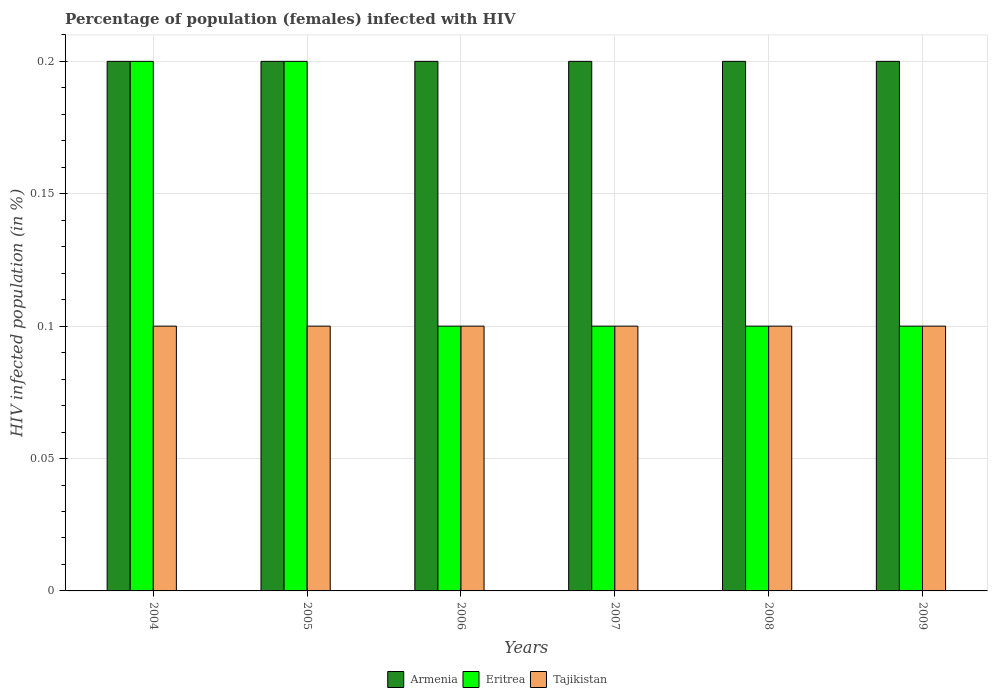Are the number of bars per tick equal to the number of legend labels?
Offer a very short reply. Yes. Are the number of bars on each tick of the X-axis equal?
Provide a short and direct response. Yes. How many bars are there on the 6th tick from the right?
Your response must be concise. 3. In how many cases, is the number of bars for a given year not equal to the number of legend labels?
Your answer should be very brief. 0. What is the percentage of HIV infected female population in Eritrea in 2009?
Make the answer very short. 0.1. Across all years, what is the minimum percentage of HIV infected female population in Tajikistan?
Ensure brevity in your answer.  0.1. In which year was the percentage of HIV infected female population in Armenia maximum?
Give a very brief answer. 2004. What is the total percentage of HIV infected female population in Tajikistan in the graph?
Offer a very short reply. 0.6. What is the difference between the percentage of HIV infected female population in Tajikistan in 2008 and that in 2009?
Make the answer very short. 0. What is the difference between the percentage of HIV infected female population in Tajikistan in 2009 and the percentage of HIV infected female population in Armenia in 2004?
Your answer should be very brief. -0.1. What is the average percentage of HIV infected female population in Eritrea per year?
Give a very brief answer. 0.13. In how many years, is the percentage of HIV infected female population in Eritrea greater than 0.17 %?
Your answer should be compact. 2. What is the ratio of the percentage of HIV infected female population in Armenia in 2004 to that in 2008?
Keep it short and to the point. 1. What is the difference between the highest and the second highest percentage of HIV infected female population in Tajikistan?
Give a very brief answer. 0. What does the 1st bar from the left in 2008 represents?
Your answer should be very brief. Armenia. What does the 1st bar from the right in 2008 represents?
Your response must be concise. Tajikistan. Is it the case that in every year, the sum of the percentage of HIV infected female population in Tajikistan and percentage of HIV infected female population in Eritrea is greater than the percentage of HIV infected female population in Armenia?
Give a very brief answer. No. How many years are there in the graph?
Your answer should be compact. 6. What is the difference between two consecutive major ticks on the Y-axis?
Provide a short and direct response. 0.05. Are the values on the major ticks of Y-axis written in scientific E-notation?
Ensure brevity in your answer.  No. Does the graph contain grids?
Ensure brevity in your answer.  Yes. What is the title of the graph?
Offer a terse response. Percentage of population (females) infected with HIV. What is the label or title of the X-axis?
Your answer should be very brief. Years. What is the label or title of the Y-axis?
Provide a short and direct response. HIV infected population (in %). What is the HIV infected population (in %) in Tajikistan in 2004?
Offer a very short reply. 0.1. What is the HIV infected population (in %) in Armenia in 2006?
Your response must be concise. 0.2. What is the HIV infected population (in %) in Eritrea in 2007?
Your response must be concise. 0.1. What is the HIV infected population (in %) in Armenia in 2008?
Give a very brief answer. 0.2. What is the HIV infected population (in %) of Eritrea in 2008?
Keep it short and to the point. 0.1. What is the HIV infected population (in %) in Tajikistan in 2008?
Provide a succinct answer. 0.1. What is the HIV infected population (in %) of Armenia in 2009?
Provide a short and direct response. 0.2. What is the HIV infected population (in %) in Eritrea in 2009?
Your answer should be compact. 0.1. What is the HIV infected population (in %) in Tajikistan in 2009?
Provide a short and direct response. 0.1. Across all years, what is the maximum HIV infected population (in %) in Eritrea?
Your response must be concise. 0.2. Across all years, what is the minimum HIV infected population (in %) in Tajikistan?
Offer a terse response. 0.1. What is the difference between the HIV infected population (in %) of Eritrea in 2004 and that in 2005?
Ensure brevity in your answer.  0. What is the difference between the HIV infected population (in %) of Tajikistan in 2004 and that in 2005?
Keep it short and to the point. 0. What is the difference between the HIV infected population (in %) of Armenia in 2004 and that in 2006?
Keep it short and to the point. 0. What is the difference between the HIV infected population (in %) of Eritrea in 2004 and that in 2006?
Offer a terse response. 0.1. What is the difference between the HIV infected population (in %) of Tajikistan in 2004 and that in 2006?
Your answer should be very brief. 0. What is the difference between the HIV infected population (in %) of Eritrea in 2004 and that in 2007?
Give a very brief answer. 0.1. What is the difference between the HIV infected population (in %) in Eritrea in 2004 and that in 2008?
Your answer should be very brief. 0.1. What is the difference between the HIV infected population (in %) of Eritrea in 2004 and that in 2009?
Give a very brief answer. 0.1. What is the difference between the HIV infected population (in %) of Tajikistan in 2004 and that in 2009?
Make the answer very short. 0. What is the difference between the HIV infected population (in %) in Armenia in 2005 and that in 2006?
Provide a short and direct response. 0. What is the difference between the HIV infected population (in %) in Tajikistan in 2005 and that in 2006?
Offer a terse response. 0. What is the difference between the HIV infected population (in %) in Tajikistan in 2005 and that in 2008?
Ensure brevity in your answer.  0. What is the difference between the HIV infected population (in %) of Armenia in 2005 and that in 2009?
Keep it short and to the point. 0. What is the difference between the HIV infected population (in %) of Eritrea in 2005 and that in 2009?
Ensure brevity in your answer.  0.1. What is the difference between the HIV infected population (in %) of Armenia in 2006 and that in 2007?
Ensure brevity in your answer.  0. What is the difference between the HIV infected population (in %) in Tajikistan in 2006 and that in 2007?
Provide a short and direct response. 0. What is the difference between the HIV infected population (in %) in Armenia in 2006 and that in 2008?
Provide a succinct answer. 0. What is the difference between the HIV infected population (in %) of Eritrea in 2006 and that in 2008?
Provide a short and direct response. 0. What is the difference between the HIV infected population (in %) in Armenia in 2006 and that in 2009?
Provide a short and direct response. 0. What is the difference between the HIV infected population (in %) in Tajikistan in 2007 and that in 2008?
Your answer should be very brief. 0. What is the difference between the HIV infected population (in %) in Tajikistan in 2007 and that in 2009?
Your answer should be very brief. 0. What is the difference between the HIV infected population (in %) of Tajikistan in 2008 and that in 2009?
Your response must be concise. 0. What is the difference between the HIV infected population (in %) of Armenia in 2004 and the HIV infected population (in %) of Eritrea in 2005?
Give a very brief answer. 0. What is the difference between the HIV infected population (in %) in Armenia in 2004 and the HIV infected population (in %) in Tajikistan in 2005?
Provide a short and direct response. 0.1. What is the difference between the HIV infected population (in %) of Armenia in 2004 and the HIV infected population (in %) of Eritrea in 2006?
Ensure brevity in your answer.  0.1. What is the difference between the HIV infected population (in %) of Eritrea in 2004 and the HIV infected population (in %) of Tajikistan in 2006?
Offer a terse response. 0.1. What is the difference between the HIV infected population (in %) of Armenia in 2004 and the HIV infected population (in %) of Eritrea in 2007?
Provide a succinct answer. 0.1. What is the difference between the HIV infected population (in %) in Armenia in 2004 and the HIV infected population (in %) in Eritrea in 2008?
Offer a terse response. 0.1. What is the difference between the HIV infected population (in %) in Armenia in 2005 and the HIV infected population (in %) in Tajikistan in 2006?
Your answer should be compact. 0.1. What is the difference between the HIV infected population (in %) of Eritrea in 2005 and the HIV infected population (in %) of Tajikistan in 2006?
Keep it short and to the point. 0.1. What is the difference between the HIV infected population (in %) of Armenia in 2005 and the HIV infected population (in %) of Tajikistan in 2007?
Offer a very short reply. 0.1. What is the difference between the HIV infected population (in %) of Eritrea in 2005 and the HIV infected population (in %) of Tajikistan in 2007?
Make the answer very short. 0.1. What is the difference between the HIV infected population (in %) of Armenia in 2005 and the HIV infected population (in %) of Tajikistan in 2008?
Offer a terse response. 0.1. What is the difference between the HIV infected population (in %) of Armenia in 2006 and the HIV infected population (in %) of Eritrea in 2007?
Provide a short and direct response. 0.1. What is the difference between the HIV infected population (in %) of Armenia in 2006 and the HIV infected population (in %) of Tajikistan in 2007?
Make the answer very short. 0.1. What is the difference between the HIV infected population (in %) in Eritrea in 2006 and the HIV infected population (in %) in Tajikistan in 2007?
Make the answer very short. 0. What is the difference between the HIV infected population (in %) in Armenia in 2006 and the HIV infected population (in %) in Eritrea in 2008?
Ensure brevity in your answer.  0.1. What is the difference between the HIV infected population (in %) in Eritrea in 2006 and the HIV infected population (in %) in Tajikistan in 2008?
Provide a short and direct response. 0. What is the difference between the HIV infected population (in %) in Armenia in 2006 and the HIV infected population (in %) in Eritrea in 2009?
Ensure brevity in your answer.  0.1. What is the difference between the HIV infected population (in %) in Armenia in 2006 and the HIV infected population (in %) in Tajikistan in 2009?
Your response must be concise. 0.1. What is the difference between the HIV infected population (in %) of Eritrea in 2006 and the HIV infected population (in %) of Tajikistan in 2009?
Your answer should be very brief. 0. What is the difference between the HIV infected population (in %) of Armenia in 2007 and the HIV infected population (in %) of Eritrea in 2008?
Offer a terse response. 0.1. What is the difference between the HIV infected population (in %) of Armenia in 2007 and the HIV infected population (in %) of Tajikistan in 2008?
Provide a succinct answer. 0.1. What is the difference between the HIV infected population (in %) of Armenia in 2007 and the HIV infected population (in %) of Eritrea in 2009?
Provide a short and direct response. 0.1. What is the difference between the HIV infected population (in %) in Armenia in 2007 and the HIV infected population (in %) in Tajikistan in 2009?
Make the answer very short. 0.1. What is the difference between the HIV infected population (in %) in Armenia in 2008 and the HIV infected population (in %) in Eritrea in 2009?
Your response must be concise. 0.1. What is the difference between the HIV infected population (in %) of Eritrea in 2008 and the HIV infected population (in %) of Tajikistan in 2009?
Your response must be concise. 0. What is the average HIV infected population (in %) of Armenia per year?
Keep it short and to the point. 0.2. What is the average HIV infected population (in %) in Eritrea per year?
Keep it short and to the point. 0.13. In the year 2004, what is the difference between the HIV infected population (in %) of Armenia and HIV infected population (in %) of Eritrea?
Ensure brevity in your answer.  0. In the year 2004, what is the difference between the HIV infected population (in %) in Armenia and HIV infected population (in %) in Tajikistan?
Provide a short and direct response. 0.1. In the year 2005, what is the difference between the HIV infected population (in %) in Armenia and HIV infected population (in %) in Tajikistan?
Provide a short and direct response. 0.1. In the year 2005, what is the difference between the HIV infected population (in %) of Eritrea and HIV infected population (in %) of Tajikistan?
Your answer should be very brief. 0.1. In the year 2006, what is the difference between the HIV infected population (in %) of Armenia and HIV infected population (in %) of Tajikistan?
Ensure brevity in your answer.  0.1. In the year 2007, what is the difference between the HIV infected population (in %) of Armenia and HIV infected population (in %) of Eritrea?
Make the answer very short. 0.1. In the year 2007, what is the difference between the HIV infected population (in %) of Armenia and HIV infected population (in %) of Tajikistan?
Offer a very short reply. 0.1. In the year 2007, what is the difference between the HIV infected population (in %) in Eritrea and HIV infected population (in %) in Tajikistan?
Provide a short and direct response. 0. In the year 2008, what is the difference between the HIV infected population (in %) of Armenia and HIV infected population (in %) of Eritrea?
Ensure brevity in your answer.  0.1. In the year 2008, what is the difference between the HIV infected population (in %) in Eritrea and HIV infected population (in %) in Tajikistan?
Offer a terse response. 0. In the year 2009, what is the difference between the HIV infected population (in %) of Armenia and HIV infected population (in %) of Eritrea?
Give a very brief answer. 0.1. In the year 2009, what is the difference between the HIV infected population (in %) in Armenia and HIV infected population (in %) in Tajikistan?
Give a very brief answer. 0.1. What is the ratio of the HIV infected population (in %) in Armenia in 2004 to that in 2005?
Your answer should be very brief. 1. What is the ratio of the HIV infected population (in %) in Eritrea in 2004 to that in 2005?
Offer a terse response. 1. What is the ratio of the HIV infected population (in %) in Armenia in 2004 to that in 2006?
Provide a short and direct response. 1. What is the ratio of the HIV infected population (in %) of Eritrea in 2004 to that in 2006?
Your answer should be very brief. 2. What is the ratio of the HIV infected population (in %) in Tajikistan in 2004 to that in 2006?
Your answer should be very brief. 1. What is the ratio of the HIV infected population (in %) of Tajikistan in 2004 to that in 2007?
Give a very brief answer. 1. What is the ratio of the HIV infected population (in %) in Armenia in 2004 to that in 2008?
Offer a very short reply. 1. What is the ratio of the HIV infected population (in %) in Armenia in 2004 to that in 2009?
Your answer should be compact. 1. What is the ratio of the HIV infected population (in %) in Tajikistan in 2004 to that in 2009?
Your answer should be very brief. 1. What is the ratio of the HIV infected population (in %) in Armenia in 2005 to that in 2006?
Provide a succinct answer. 1. What is the ratio of the HIV infected population (in %) in Tajikistan in 2005 to that in 2006?
Offer a terse response. 1. What is the ratio of the HIV infected population (in %) in Armenia in 2005 to that in 2007?
Ensure brevity in your answer.  1. What is the ratio of the HIV infected population (in %) in Eritrea in 2005 to that in 2007?
Make the answer very short. 2. What is the ratio of the HIV infected population (in %) of Armenia in 2005 to that in 2008?
Your answer should be very brief. 1. What is the ratio of the HIV infected population (in %) of Armenia in 2005 to that in 2009?
Keep it short and to the point. 1. What is the ratio of the HIV infected population (in %) of Armenia in 2006 to that in 2007?
Ensure brevity in your answer.  1. What is the ratio of the HIV infected population (in %) in Armenia in 2006 to that in 2008?
Make the answer very short. 1. What is the ratio of the HIV infected population (in %) in Tajikistan in 2006 to that in 2009?
Offer a very short reply. 1. What is the ratio of the HIV infected population (in %) of Armenia in 2007 to that in 2008?
Provide a succinct answer. 1. What is the ratio of the HIV infected population (in %) of Eritrea in 2007 to that in 2009?
Give a very brief answer. 1. What is the ratio of the HIV infected population (in %) in Tajikistan in 2007 to that in 2009?
Your answer should be compact. 1. What is the ratio of the HIV infected population (in %) of Armenia in 2008 to that in 2009?
Provide a short and direct response. 1. What is the ratio of the HIV infected population (in %) of Eritrea in 2008 to that in 2009?
Provide a short and direct response. 1. What is the difference between the highest and the second highest HIV infected population (in %) in Armenia?
Offer a very short reply. 0. What is the difference between the highest and the second highest HIV infected population (in %) of Eritrea?
Offer a terse response. 0. What is the difference between the highest and the lowest HIV infected population (in %) of Eritrea?
Provide a short and direct response. 0.1. What is the difference between the highest and the lowest HIV infected population (in %) in Tajikistan?
Offer a terse response. 0. 